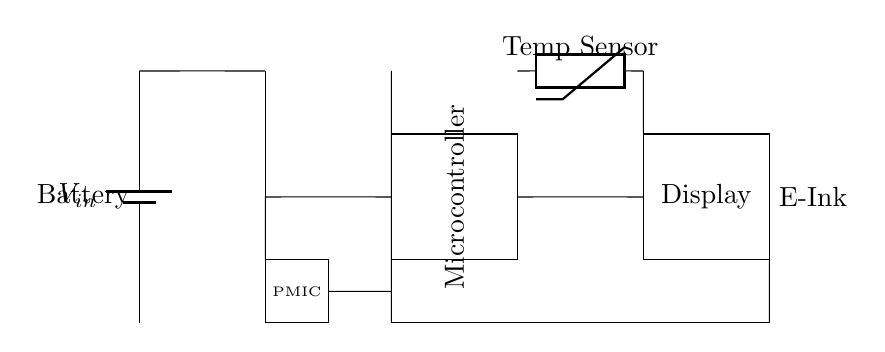What is the input voltage for this circuit? The input voltage is represented by the component labeled as V_in, which is a battery. The diagram indicates this is the starting voltage for the circuit.
Answer: V_in What type of voltage regulation is used? The diagram shows an LDO (Low Dropout Regulator) between the input and the microcontroller. This implies a specific type of voltage regulation suited for low power conditions.
Answer: LDO Regulator How many main components are in the circuit? The diagram comprises several main components: the battery, LDO regulator, microcontroller, display, temperature sensor, and power management IC (PMIC). Count all unique components to get the total.
Answer: Six What is the function of the PMIC in this circuit? The PMIC (Power Management IC) manages the distribution of power throughout the circuit, ensuring that all components receive the voltage they need for optimal operation. Its placement before the microcontroller indicates its role in power governance.
Answer: Power management What is the purpose of the thermistor? The thermistor is used as a temperature sensor; it measures the temperature and relays this information to the microcontroller for processing, which is essential for a smart thermostat functionality.
Answer: Temperature sensing Which component is responsible for the display output? The component labeled as "Display" indicates where the visual output is generated. In the context of a smart thermostat, this would generally be an E-Ink display to show temperature readings or settings.
Answer: Display What type of display is used in this circuit? The diagram specifies the display as E-Ink, which is known for low power consumption and readability in various lighting conditions, making it ideal for battery-operated devices like smart thermostats.
Answer: E-Ink 